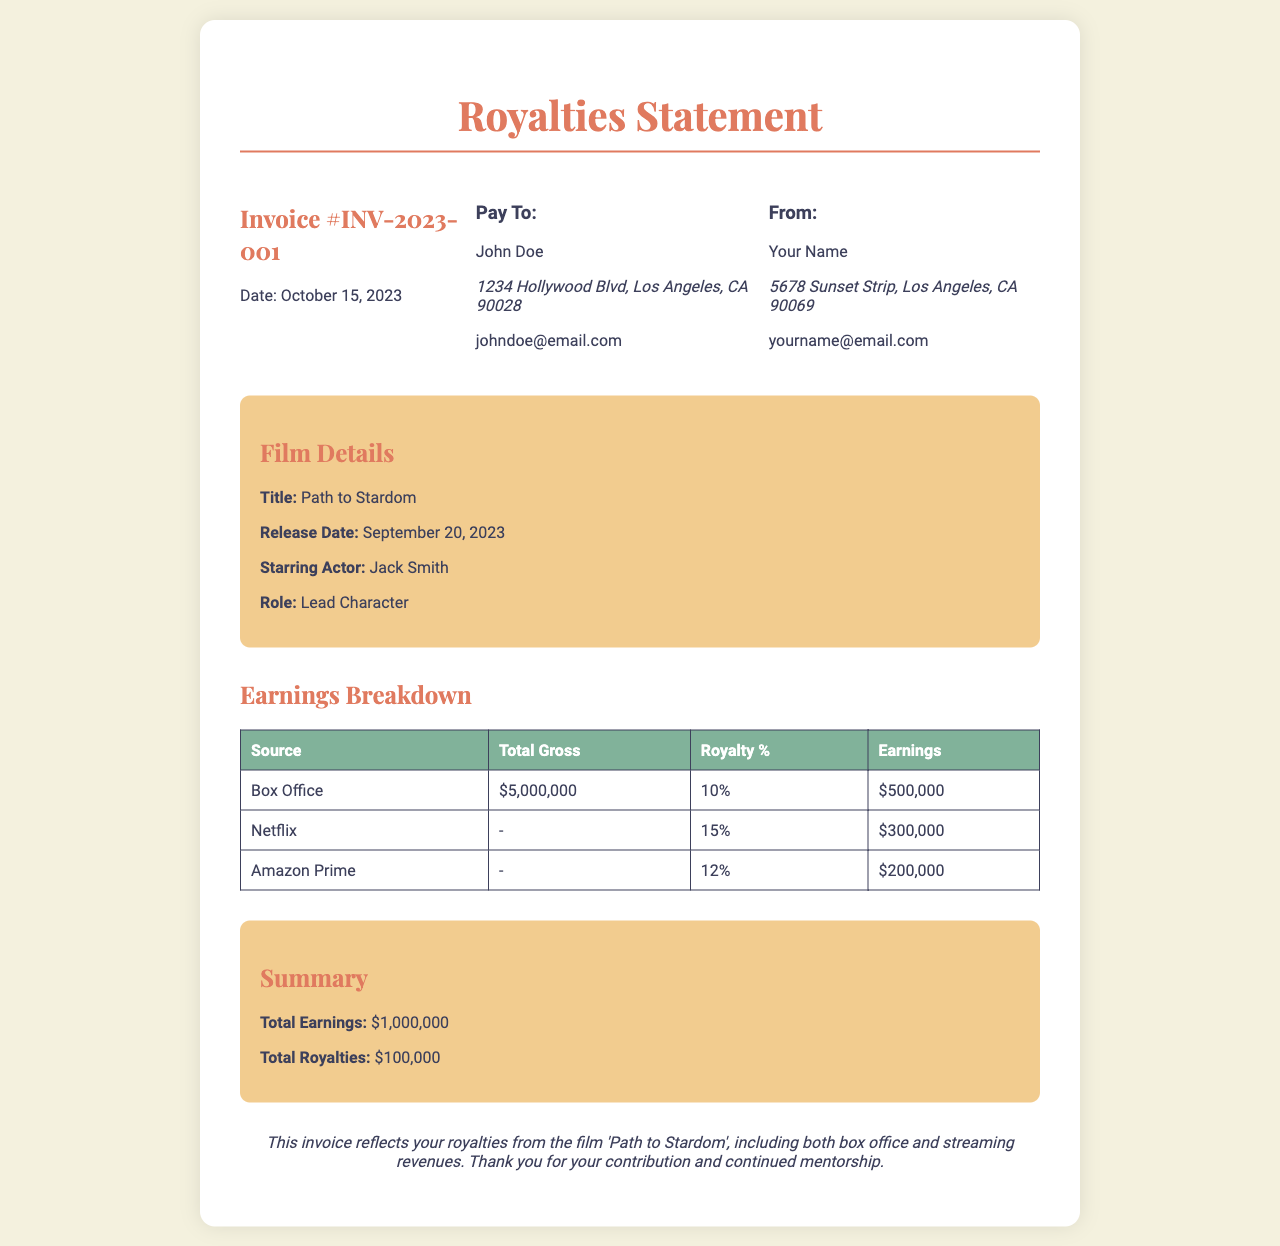what is the invoice number? The invoice number is specified at the top of the document under the invoice heading, which is INV-2023-001.
Answer: INV-2023-001 who is the starring actor? The starring actor's name is mentioned in the film details section of the document as Jack Smith.
Answer: Jack Smith what is the total gross from the box office? The box office gross is clearly stated in the earnings breakdown table as $5,000,000.
Answer: $5,000,000 what is the release date of the film? The release date is specified under the film details section of the document, which is September 20, 2023.
Answer: September 20, 2023 how much did the actor earn from Amazon Prime? The earnings from Amazon Prime are provided in the earnings breakdown table as $200,000.
Answer: $200,000 what is the royalty percentage for Netflix? The royalty percentage for Netflix is stated in the earnings breakdown table as 15%.
Answer: 15% what is the total earnings from all sources? The total earnings are summarized at the end of the document and equal $1,000,000.
Answer: $1,000,000 what is the summary of total royalties? The total royalties are presented in the summary section of the document as $100,000.
Answer: $100,000 what type of document is this? The document serves as a statement that outlines the royalties received from the film, categorized by earnings sources.
Answer: Royalties Statement 